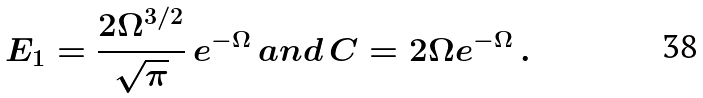Convert formula to latex. <formula><loc_0><loc_0><loc_500><loc_500>E _ { 1 } = \frac { 2 \Omega ^ { 3 / 2 } } { \sqrt { \pi } } \, e ^ { - \Omega } \, a n d \, C = 2 \Omega e ^ { - \Omega } \, .</formula> 